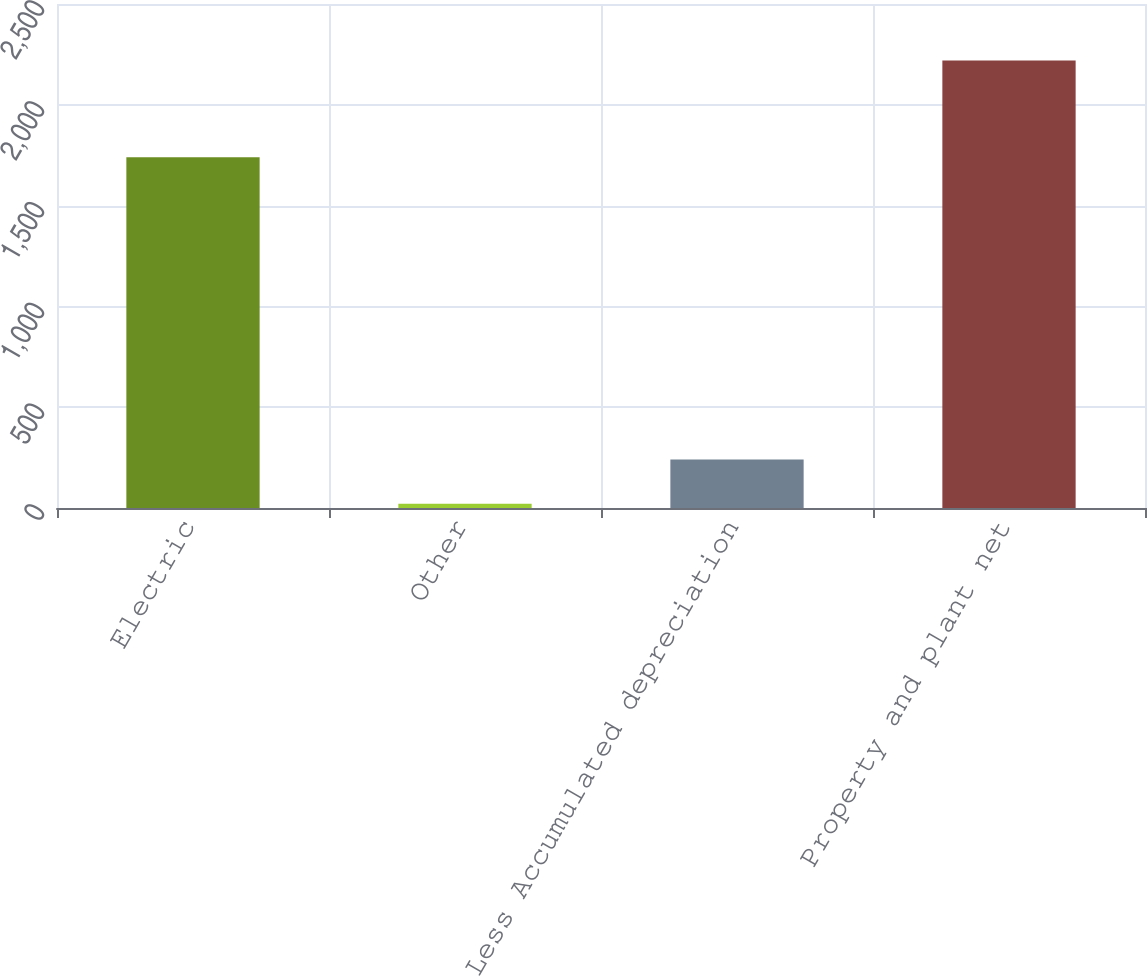<chart> <loc_0><loc_0><loc_500><loc_500><bar_chart><fcel>Electric<fcel>Other<fcel>Less Accumulated depreciation<fcel>Property and plant net<nl><fcel>1740<fcel>21<fcel>240.9<fcel>2220<nl></chart> 